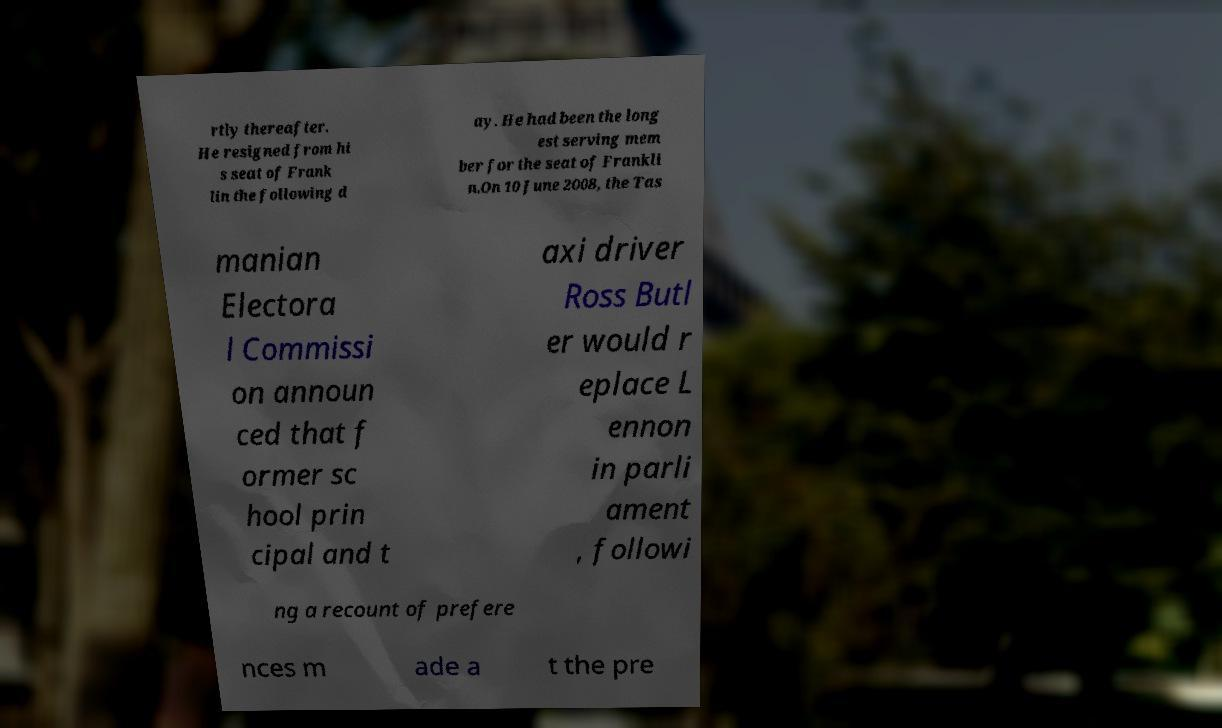For documentation purposes, I need the text within this image transcribed. Could you provide that? rtly thereafter. He resigned from hi s seat of Frank lin the following d ay. He had been the long est serving mem ber for the seat of Frankli n.On 10 June 2008, the Tas manian Electora l Commissi on announ ced that f ormer sc hool prin cipal and t axi driver Ross Butl er would r eplace L ennon in parli ament , followi ng a recount of prefere nces m ade a t the pre 